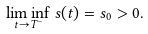<formula> <loc_0><loc_0><loc_500><loc_500>\liminf _ { t \rightarrow T ^ { - } } s ( t ) = s _ { 0 } > 0 .</formula> 